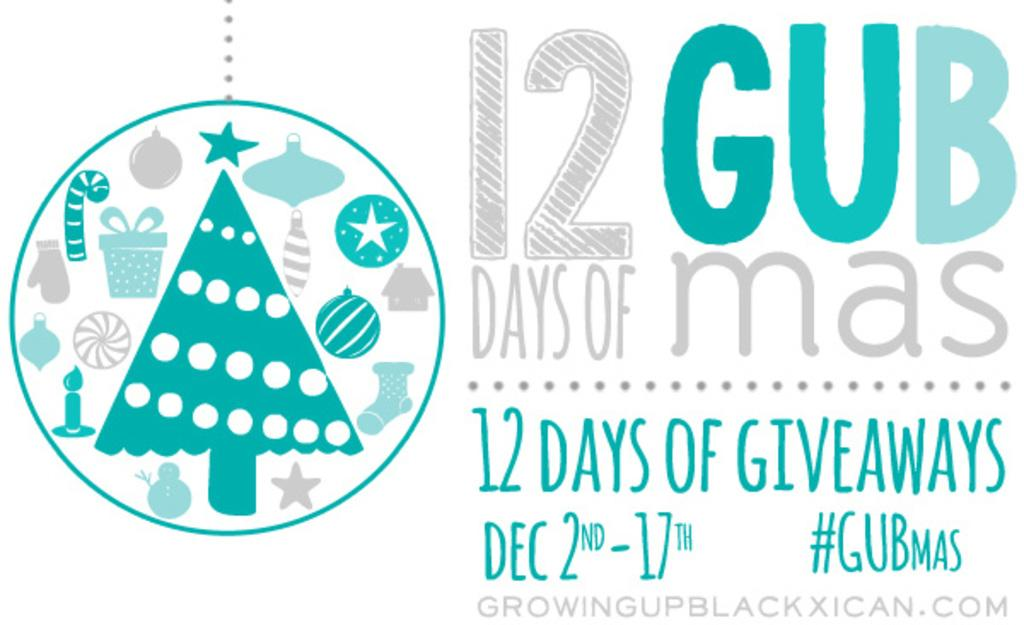What type of visual is depicted in the image? The image appears to be a poster. What can be found on the left side of the poster? There are clip art images on the left side of the poster. What is located on the right side of the poster? There is text on the right side of the poster. What type of knife is being used to drain the minister in the image? There is no knife or minister present in the image; it only features clip art images and text on a poster. 